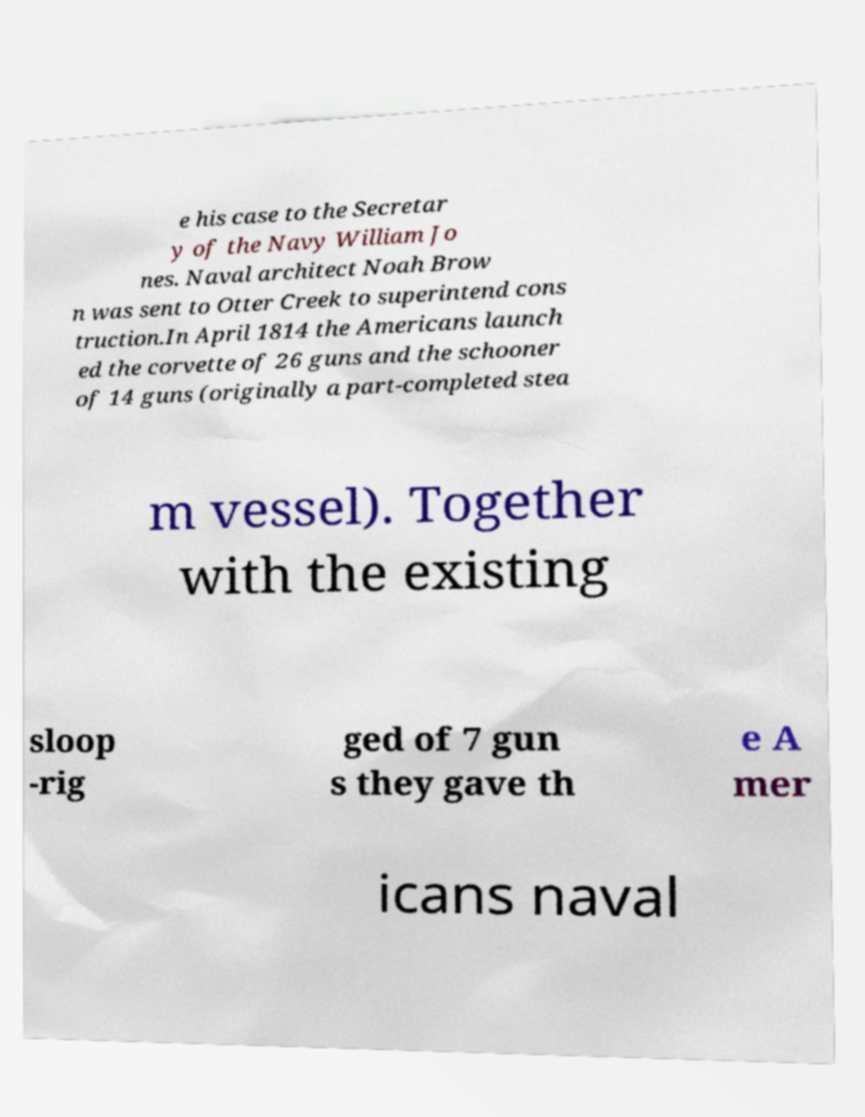Could you extract and type out the text from this image? e his case to the Secretar y of the Navy William Jo nes. Naval architect Noah Brow n was sent to Otter Creek to superintend cons truction.In April 1814 the Americans launch ed the corvette of 26 guns and the schooner of 14 guns (originally a part-completed stea m vessel). Together with the existing sloop -rig ged of 7 gun s they gave th e A mer icans naval 